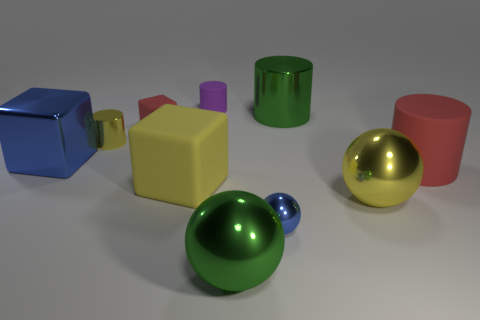Is there a blue metal sphere that has the same size as the yellow rubber object?
Provide a short and direct response. No. The tiny cylinder behind the yellow object behind the blue block that is behind the big green metallic sphere is made of what material?
Your answer should be compact. Rubber. There is a red matte thing right of the large green shiny sphere; how many blue shiny blocks are in front of it?
Provide a succinct answer. 0. Is the size of the red matte thing that is on the left side of the blue ball the same as the purple object?
Your answer should be compact. Yes. How many big red objects are the same shape as the large yellow metal object?
Keep it short and to the point. 0. The small red matte thing is what shape?
Offer a very short reply. Cube. Are there the same number of small yellow cylinders left of the big blue object and small green matte cylinders?
Give a very brief answer. Yes. Are the big cube that is on the right side of the metallic block and the tiny sphere made of the same material?
Offer a very short reply. No. Is the number of small rubber blocks that are in front of the small yellow thing less than the number of tiny green cylinders?
Your answer should be very brief. No. What number of rubber things are cylinders or green spheres?
Give a very brief answer. 2. 